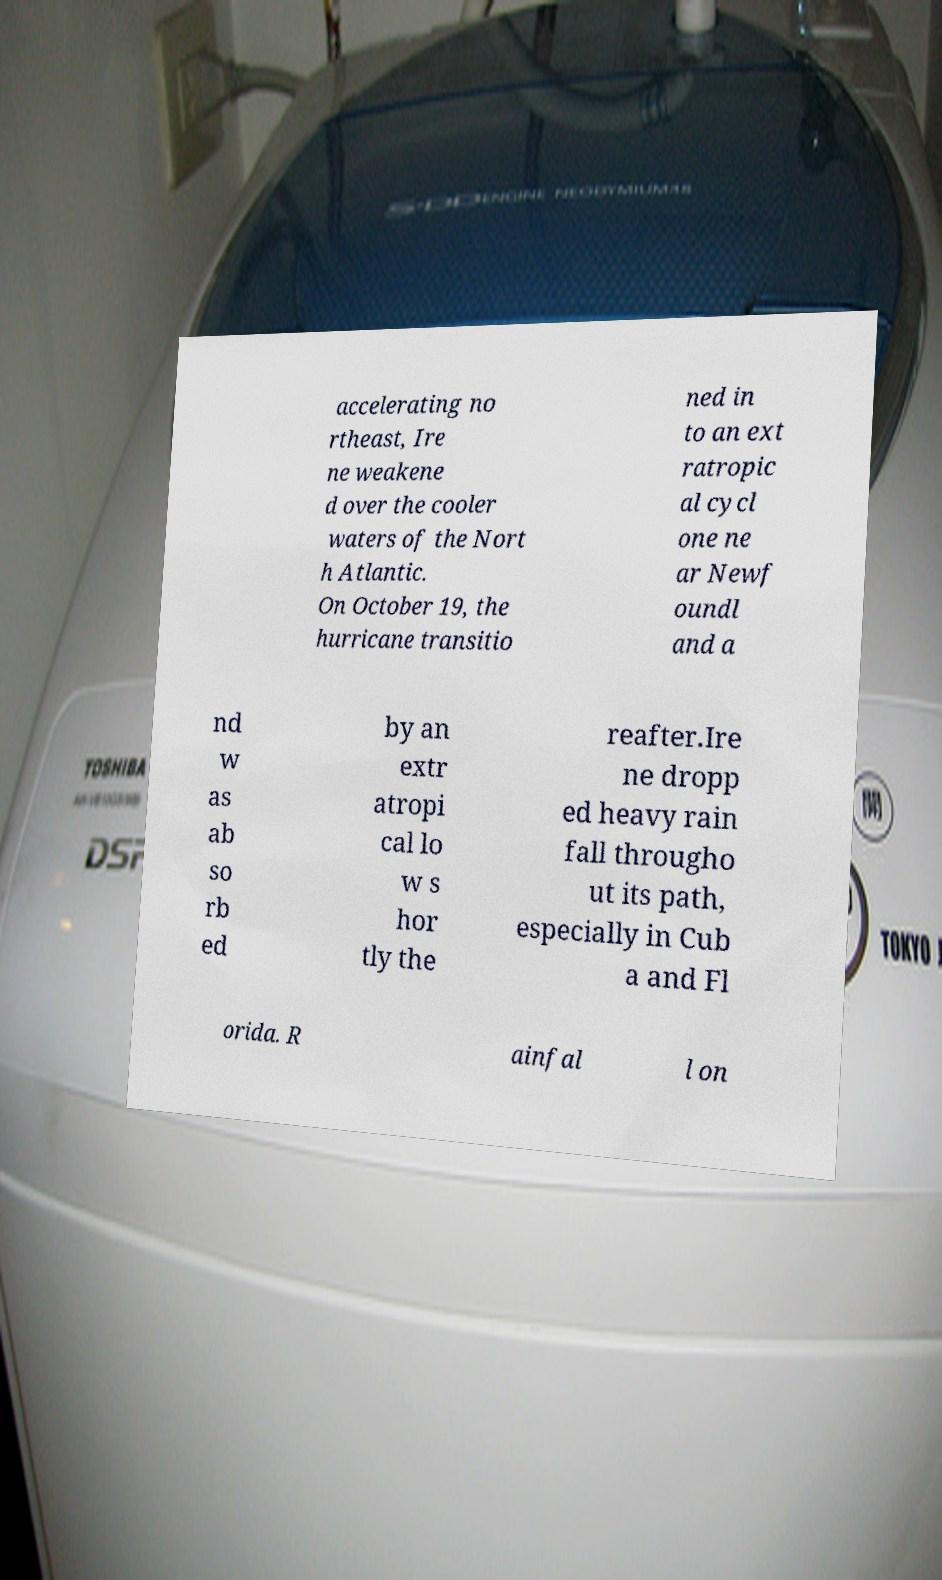Can you read and provide the text displayed in the image?This photo seems to have some interesting text. Can you extract and type it out for me? accelerating no rtheast, Ire ne weakene d over the cooler waters of the Nort h Atlantic. On October 19, the hurricane transitio ned in to an ext ratropic al cycl one ne ar Newf oundl and a nd w as ab so rb ed by an extr atropi cal lo w s hor tly the reafter.Ire ne dropp ed heavy rain fall througho ut its path, especially in Cub a and Fl orida. R ainfal l on 